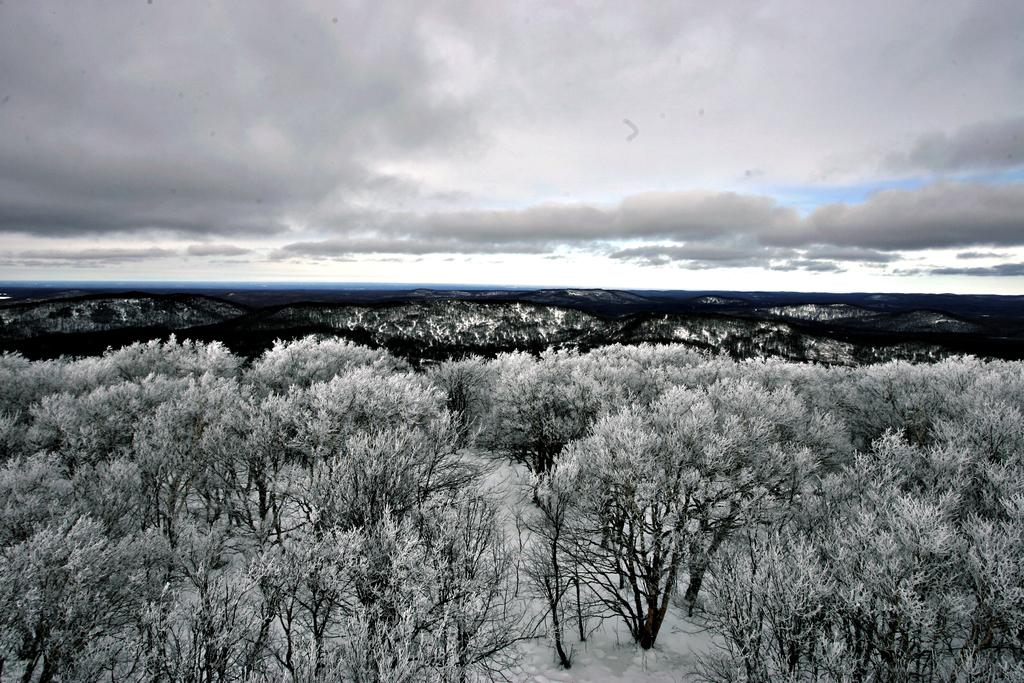What can be observed about the image that suggests it has been edited? The image appears to be edited, but the specific editing techniques or effects are not mentioned in the facts. What type of natural environment is depicted in the image? The image contains trees and hills, which are part of a natural environment. What is visible at the top of the image? The sky is visible at the top of the image. What is the weather like in the image? The sky is cloudy in the image, which suggests a cloudy or overcast weather condition. What type of grass is being served for dinner in the image? There is no grass or dinner present in the image; it features trees, hills, and a cloudy sky. Can you tell me how many chickens are visible in the image? There are no chickens present in the image. 